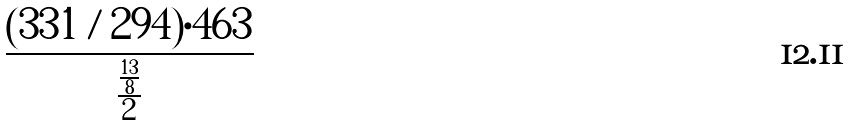<formula> <loc_0><loc_0><loc_500><loc_500>\frac { ( 3 3 1 / 2 9 4 ) \cdot 4 6 3 } { \frac { \frac { 1 3 } { 8 } } { 2 } }</formula> 